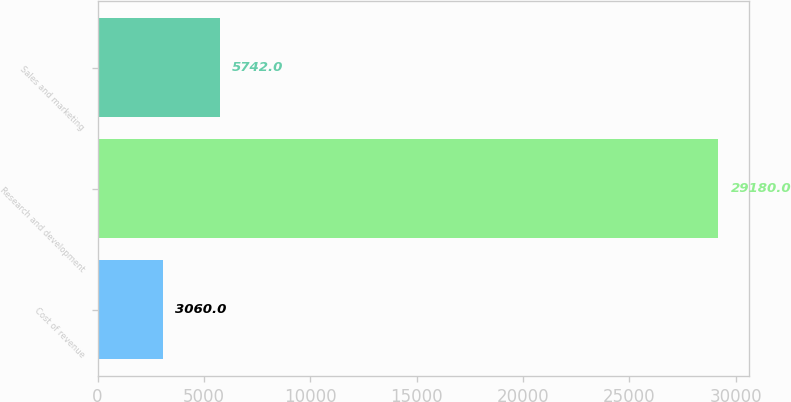Convert chart to OTSL. <chart><loc_0><loc_0><loc_500><loc_500><bar_chart><fcel>Cost of revenue<fcel>Research and development<fcel>Sales and marketing<nl><fcel>3060<fcel>29180<fcel>5742<nl></chart> 